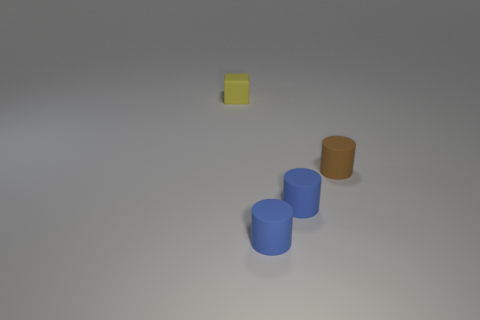Are there any brown cylinders of the same size as the brown object?
Offer a terse response. No. How many blue things are small cubes or big rubber things?
Offer a terse response. 0. Is there anything else that has the same shape as the tiny yellow thing?
Your answer should be very brief. No. What number of cylinders are tiny matte objects or shiny things?
Your answer should be compact. 3. What is the color of the small thing behind the brown thing?
Your response must be concise. Yellow. The brown thing that is the same size as the yellow block is what shape?
Give a very brief answer. Cylinder. There is a small brown object; how many yellow matte cubes are in front of it?
Offer a terse response. 0. What number of things are either small brown matte things or big blue shiny spheres?
Provide a short and direct response. 1. How many blue things are there?
Provide a succinct answer. 2. What color is the small cube that is made of the same material as the tiny brown cylinder?
Your answer should be compact. Yellow. 